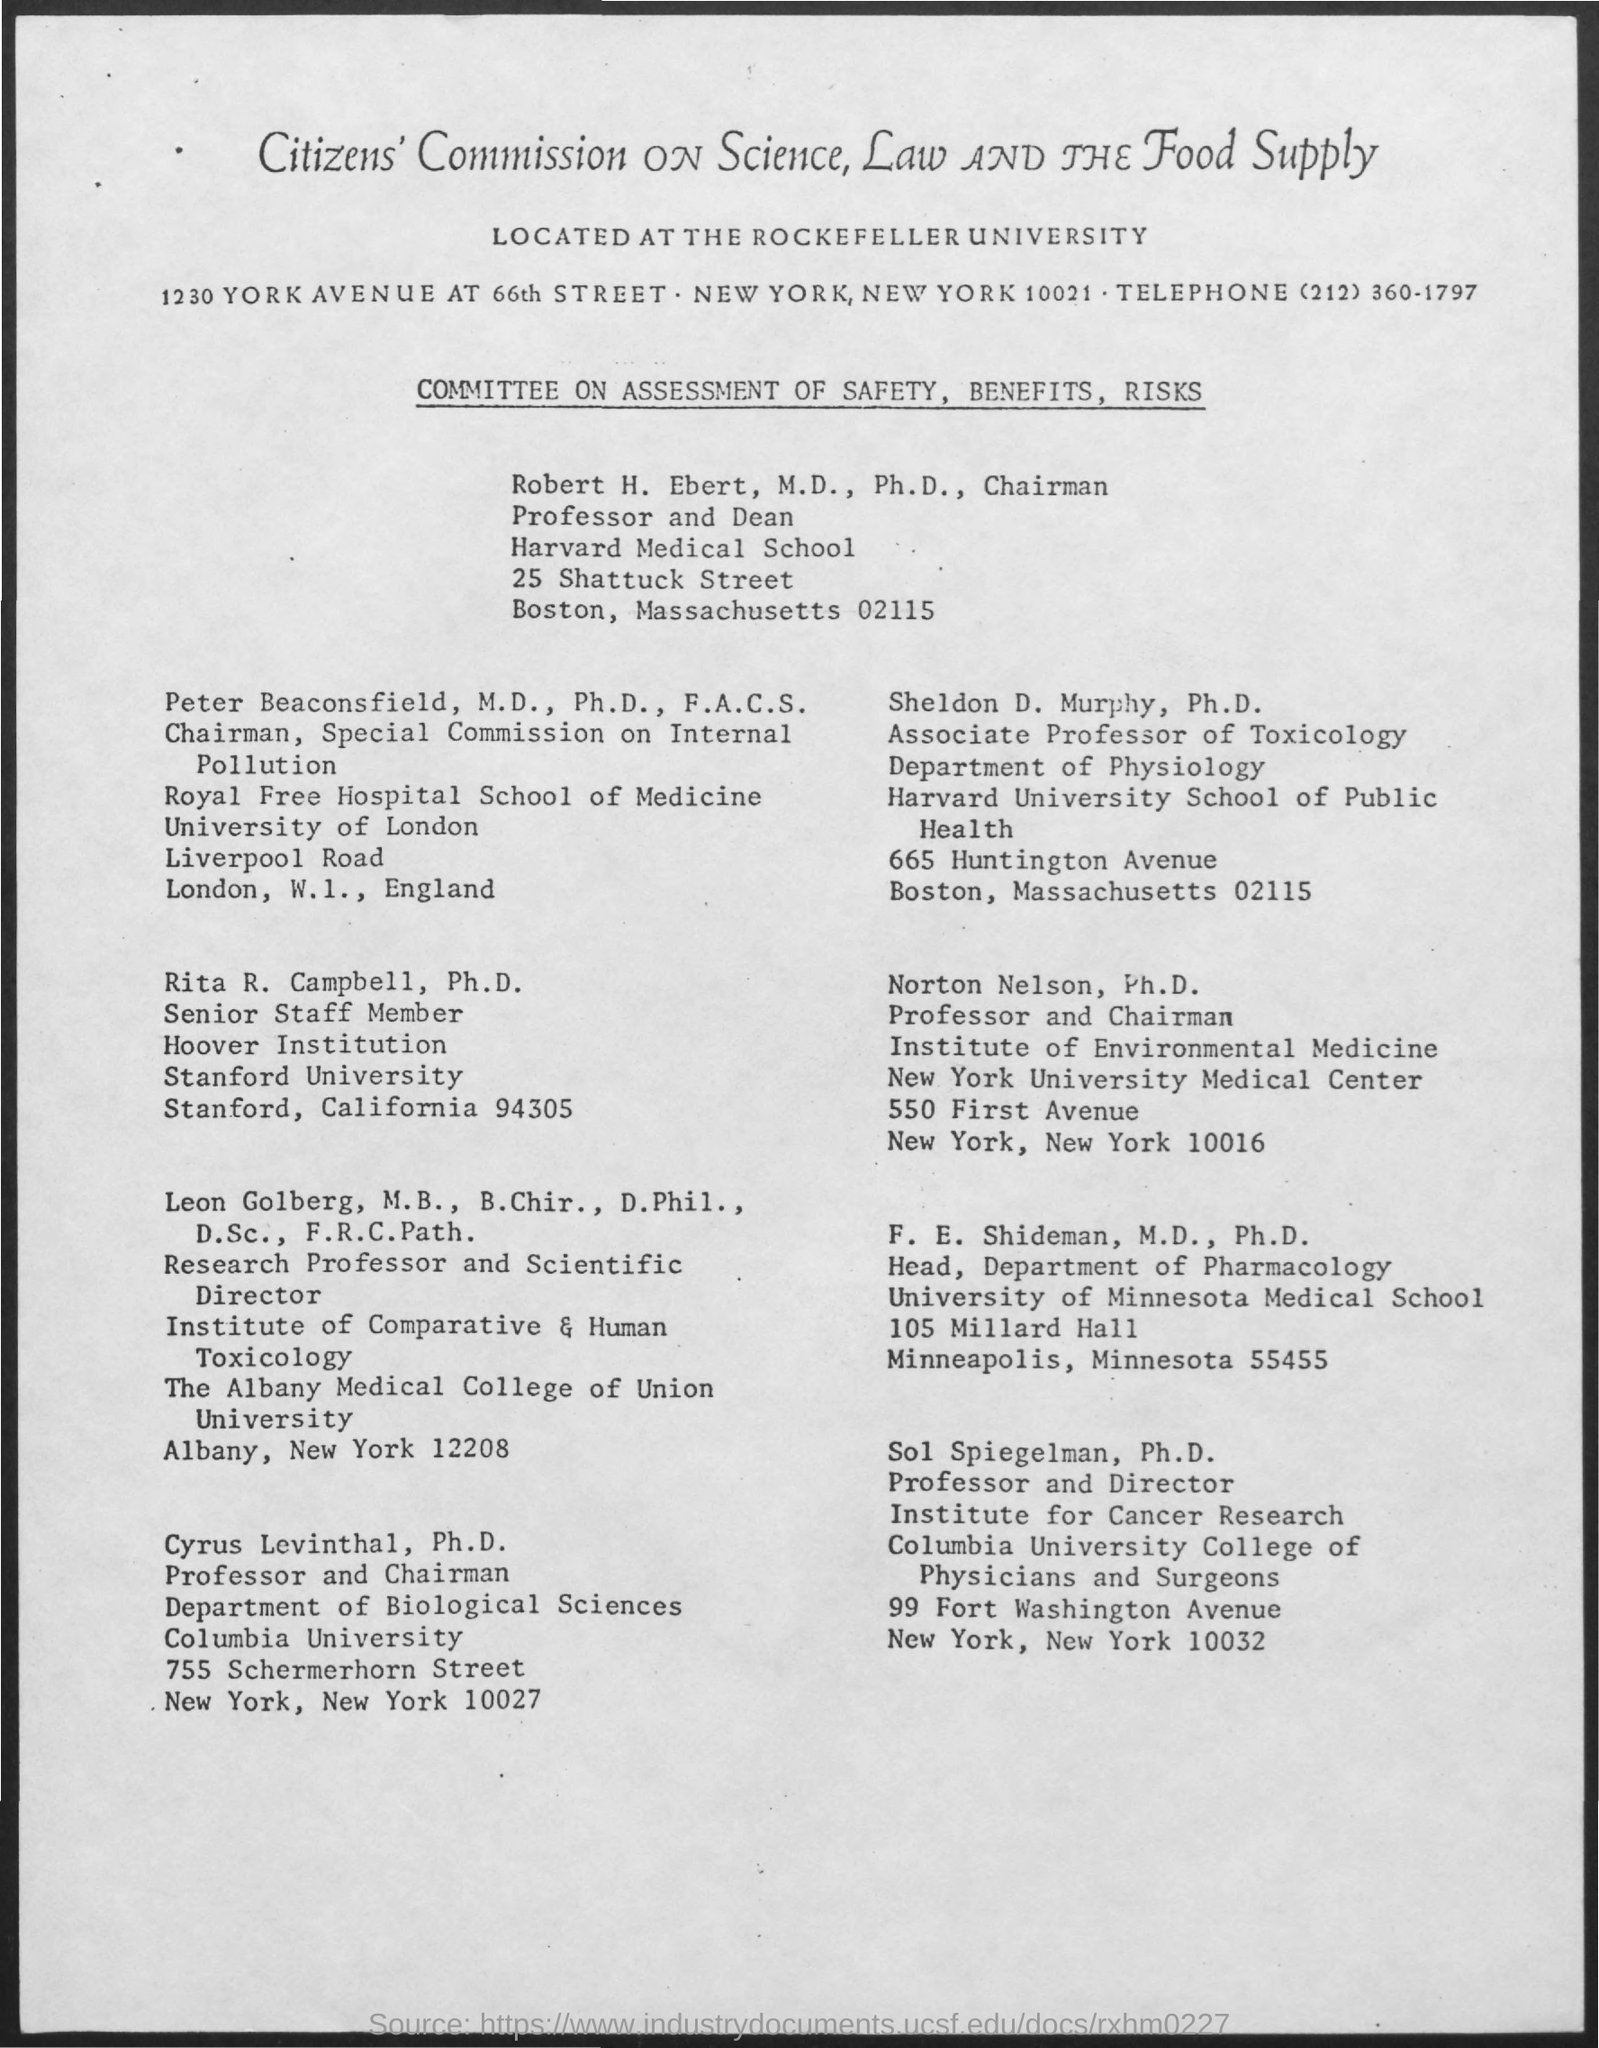What commission's name is mentioned in the title?
Keep it short and to the point. Citizens' Commission on science,law and the food supply. What is the telephone number?
Give a very brief answer. (212) 360-1797. Who is the Associate Professor of Toxicology?
Keep it short and to the point. Sheldon D. Murphy. Who is the Head of the Department of Pharmacology?
Give a very brief answer. F. e. shideman, m.d., ph.d. Who is the Professor and Director of the Institute for Cancer Research?
Make the answer very short. Sol Spiegelman. Who is the Professor and Chairman of the Department of Biological Sciences?
Give a very brief answer. Cyrus Levinthal. 